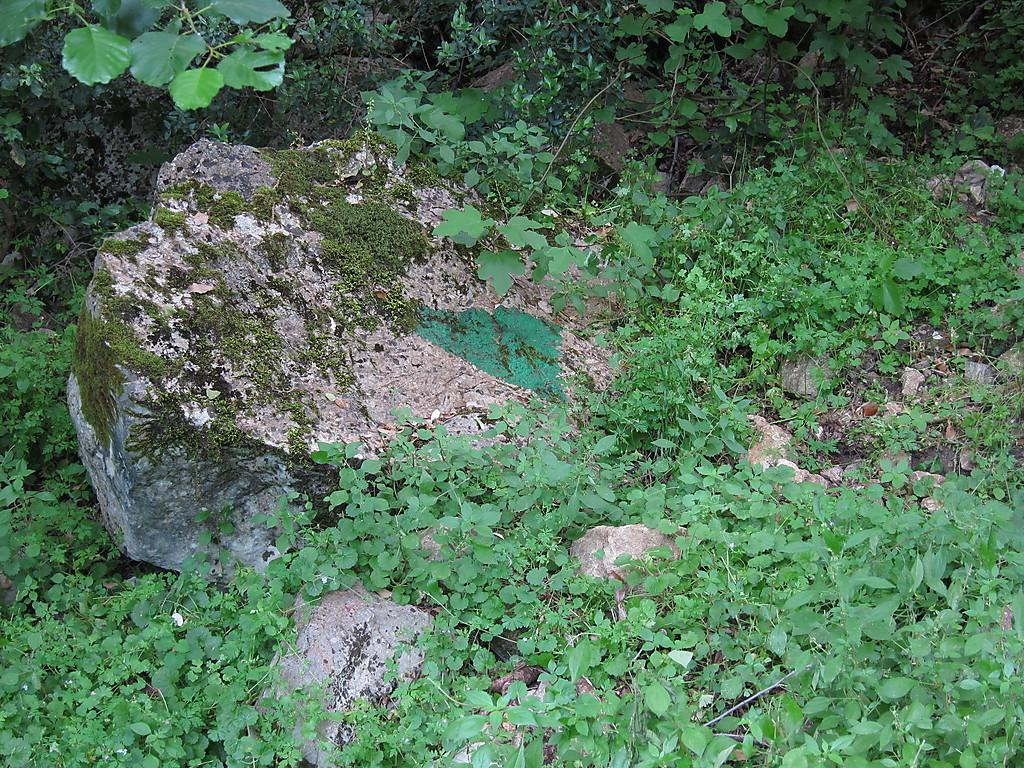What type of vegetation is present on the ground in the image? There are plants on the ground in the image. What other objects can be seen in the image? There are stones visible in the image. Where are leaves visible in the image? Leaves are visible in the top right and top left of the image. What type of blade is being used to cut the leaves in the image? There is no blade or cutting activity present in the image. How many horses are visible in the image? There are no horses present in the image. 